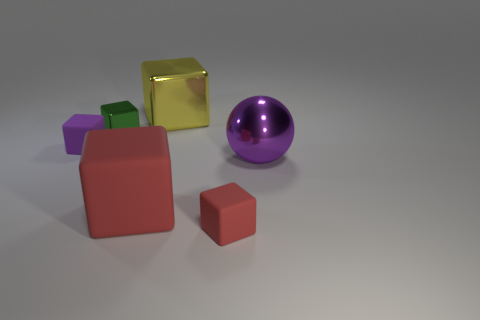What number of other objects are the same shape as the yellow thing?
Give a very brief answer. 4. What is the size of the cube that is both to the left of the yellow block and behind the purple matte thing?
Keep it short and to the point. Small. Is the size of the yellow shiny thing the same as the green block?
Offer a terse response. No. Is the color of the tiny object in front of the purple cube the same as the large shiny ball?
Provide a succinct answer. No. There is a tiny metal object; how many small objects are in front of it?
Provide a succinct answer. 2. Is the number of tiny purple rubber objects greater than the number of small matte blocks?
Offer a terse response. No. There is a rubber thing that is both in front of the purple matte block and behind the small red thing; what is its shape?
Provide a succinct answer. Cube. Is there a brown matte block?
Offer a very short reply. No. There is a green thing that is the same shape as the yellow thing; what is it made of?
Offer a terse response. Metal. There is a red object that is left of the tiny thing that is in front of the large block in front of the big yellow metal block; what is its shape?
Give a very brief answer. Cube. 